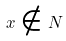<formula> <loc_0><loc_0><loc_500><loc_500>x \notin N</formula> 